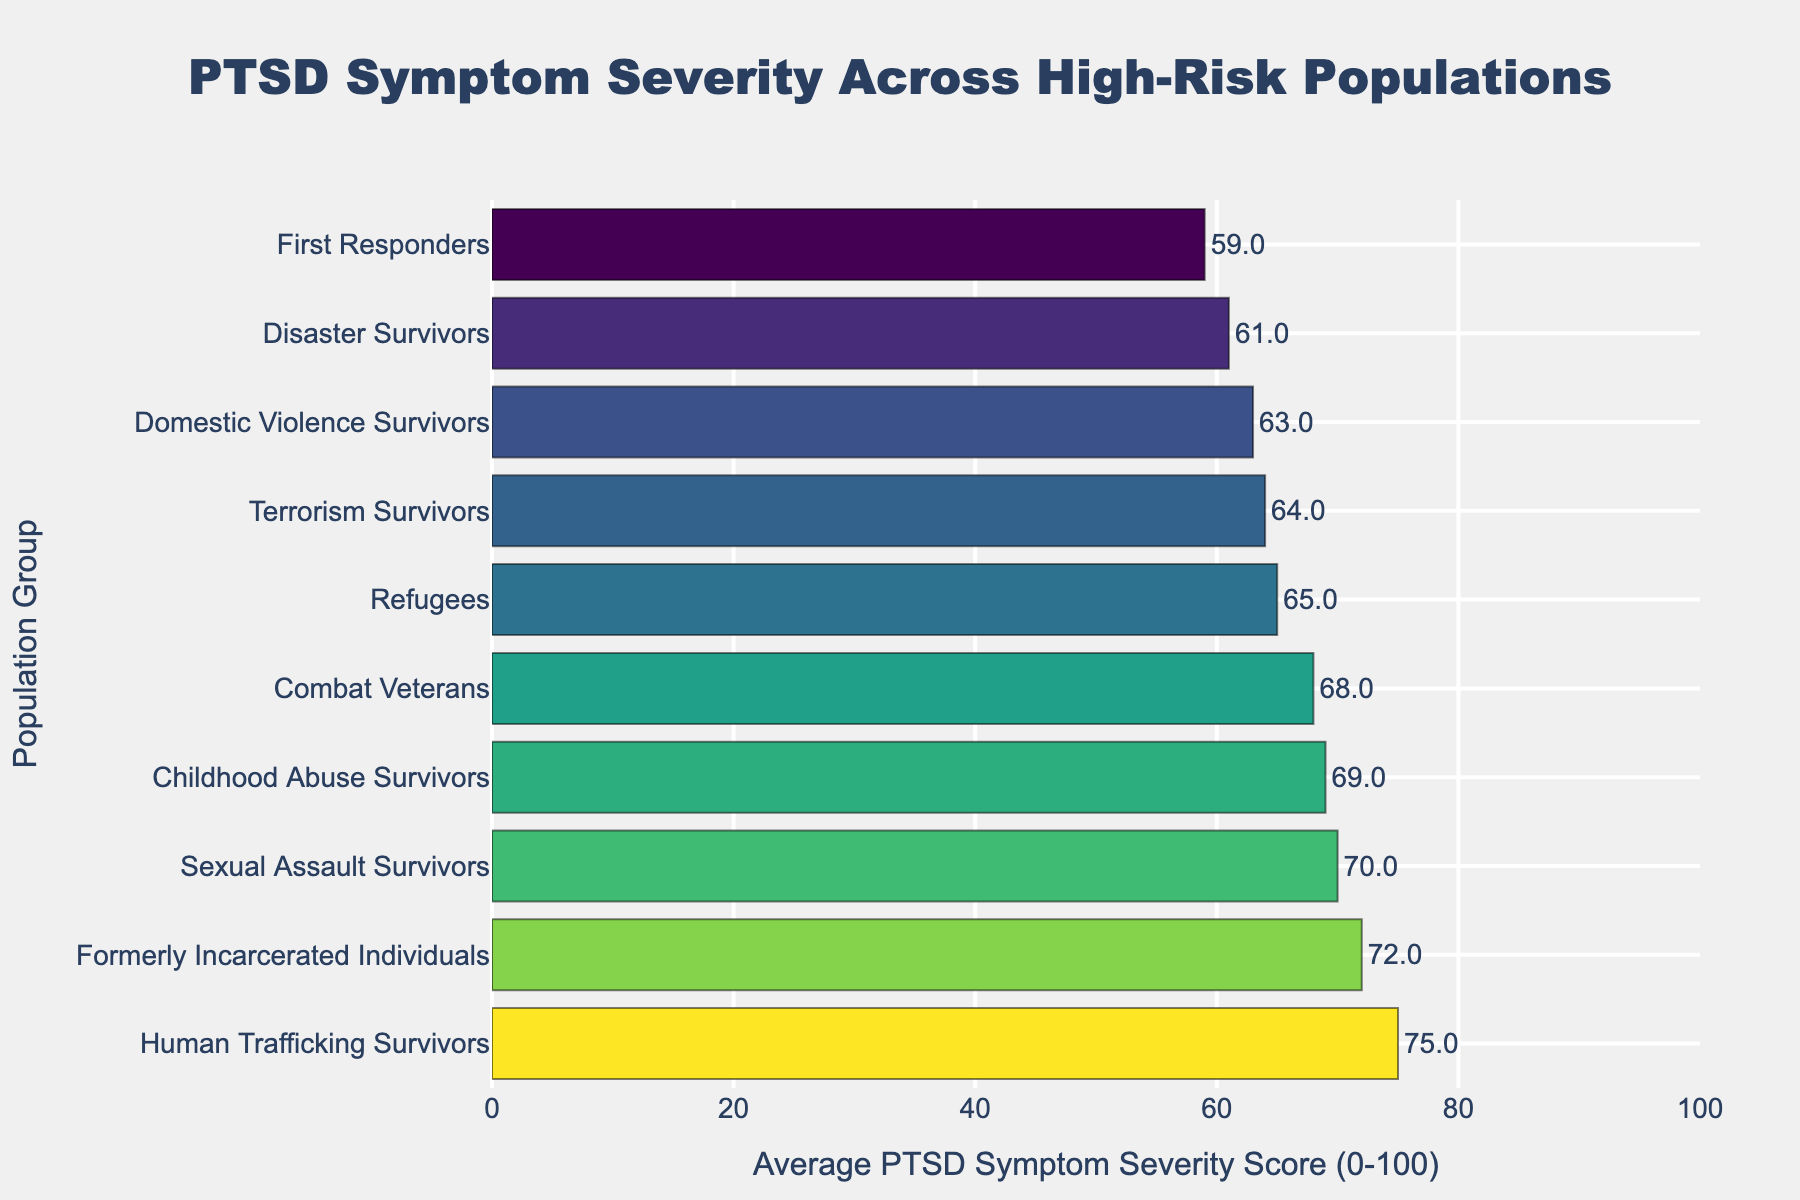What is the average PTSD symptom severity score for combat veterans? Refer to the bar labeled "Combat Veterans" to determine its position on the x-axis. The score is listed as "68".
Answer: 68 Which group has the highest average PTSD symptom severity score? Identify the group with the longest bar, the "Human Trafficking Survivors" group, which has a score of 75.
Answer: Human Trafficking Survivors How much higher is the average PTSD symptom severity score for formerly incarcerated individuals compared to disaster survivors? Subtract the severity score for "Disaster Survivors" (61) from that of the "Formerly Incarcerated Individuals" (72). 72-61 = 11.
Answer: 11 Which groups have an average PTSD symptom severity score greater than 65? Identify the bars that extend past the 65 mark on the x-axis. The groups are "Formerly Incarcerated Individuals," "Combat Veterans," "Sexual Assault Survivors," "Human Trafficking Survivors," and "Childhood Abuse Survivors."
Answer: Five groups What is the combined average PTSD symptom severity score for domestic violence survivors and refugees? Add the scores for "Domestic Violence Survivors" (63) and "Refugees" (65). 63 + 65 = 128
Answer: 128 Which group has a lower PTSD symptom severity score: first responders or childhood abuse survivors? Compare the x-axis positions of "First Responders" (59) and "Childhood Abuse Survivors" (69). "First Responders" have a lower score.
Answer: First Responders What is the difference in average PTSD symptom severity scores between the group with the highest score and the group with the lowest score? Subtract the lowest score (First Responders, 59) from the highest score (Human Trafficking Survivors, 75). 75 - 59 = 16.
Answer: 16 How many groups have a PTSD score between 60 and 70? Count the number of bars that fall between the 60 and 70 marks on the x-axis. The groups are "Disaster Survivors," "Refugees," "Domestic Violence Survivors," "Terrorism Survivors," and "Childhood Abuse Survivors."
Answer: Five groups Which group has the closest PTSD symptom severity score to 70? Find the group closest to the 70 mark on the x-axis. The group is "Sexual Assault Survivors" with a score of 70.
Answer: Sexual Assault Survivors Are there more groups with PTSD symptom severity scores above 65 or below 65? Count the number of bars that fall above and below the 65 mark on the x-axis. Above 65: Five groups; below 65: Five groups. They are equal.
Answer: Equal 